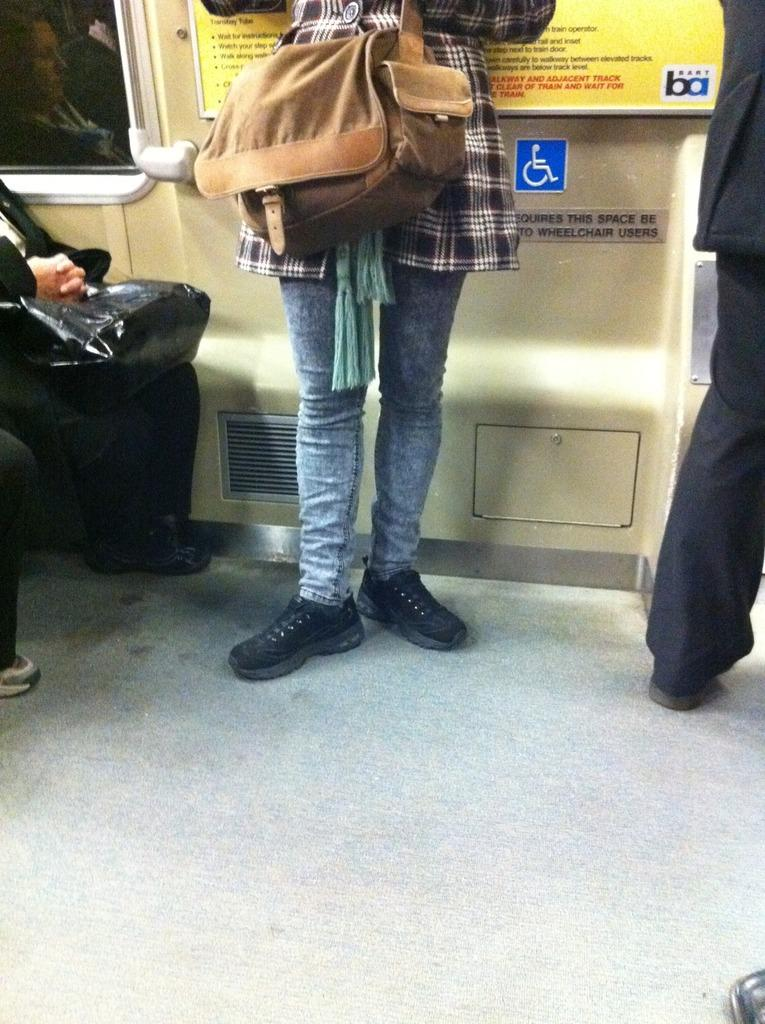What is the woman in the image wearing? The woman is wearing a brown bag in the image. What is the woman's posture in the image? The woman is standing in the image. How many people are sitting beside the woman? There are two people sitting beside the woman in the image. Is there anyone else standing in the image besides the woman? Yes, there is another person standing on the other side of the woman. Can you see the woman's kitty sleeping on her tongue in the image? There is no kitty or tongue visible in the image, and the woman is not depicted as sleeping. 